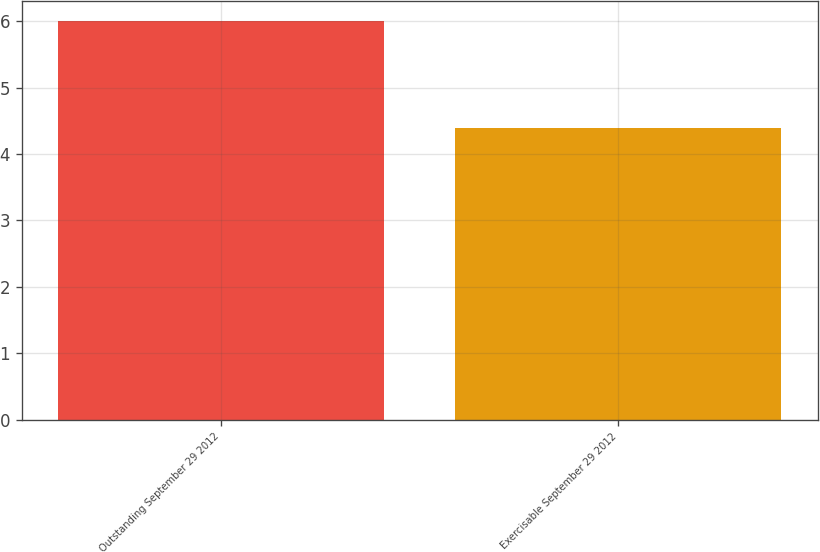Convert chart to OTSL. <chart><loc_0><loc_0><loc_500><loc_500><bar_chart><fcel>Outstanding September 29 2012<fcel>Exercisable September 29 2012<nl><fcel>6<fcel>4.4<nl></chart> 